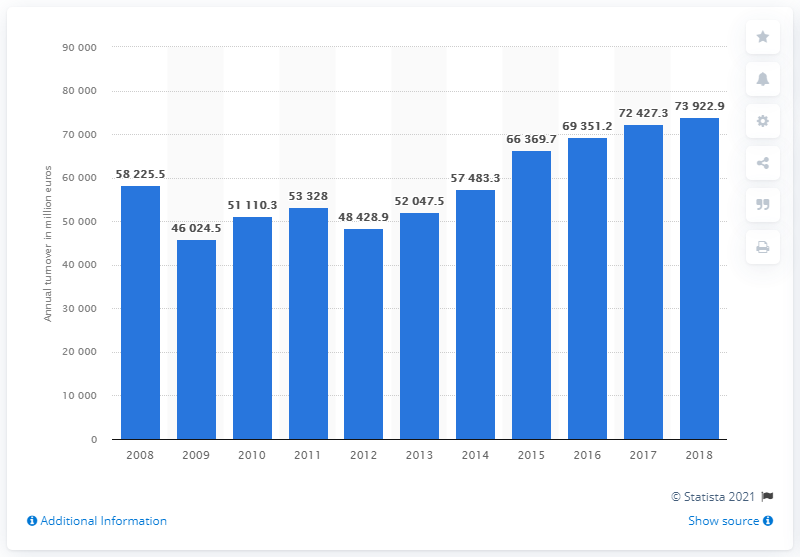Indicate a few pertinent items in this graphic. In 2016, the turnover of Spain's motor vehicle, trailer and semi-trailer industry was 69,351.2. 